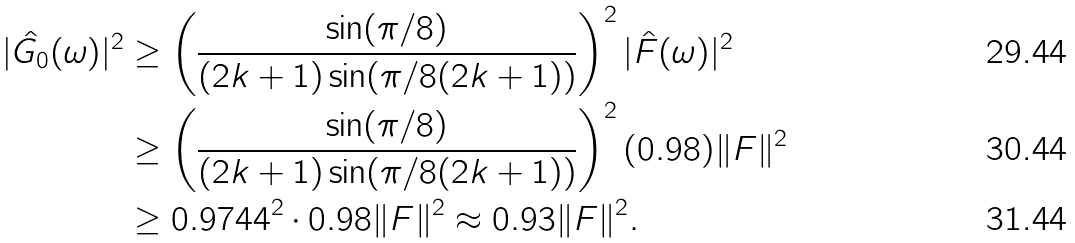<formula> <loc_0><loc_0><loc_500><loc_500>| \hat { G _ { 0 } } ( \omega ) | ^ { 2 } & \geq \left ( \frac { \sin ( \pi / 8 ) } { ( 2 k + 1 ) \sin ( \pi / 8 ( 2 k + 1 ) ) } \right ) ^ { 2 } | \hat { F } ( \omega ) | ^ { 2 } \\ & \geq \left ( \frac { \sin ( \pi / 8 ) } { ( 2 k + 1 ) \sin ( \pi / 8 ( 2 k + 1 ) ) } \right ) ^ { 2 } ( 0 . 9 8 ) \| F \| ^ { 2 } \\ & \geq 0 . 9 7 4 4 ^ { 2 } \cdot 0 . 9 8 \| F \| ^ { 2 } \approx 0 . 9 3 \| F \| ^ { 2 } .</formula> 